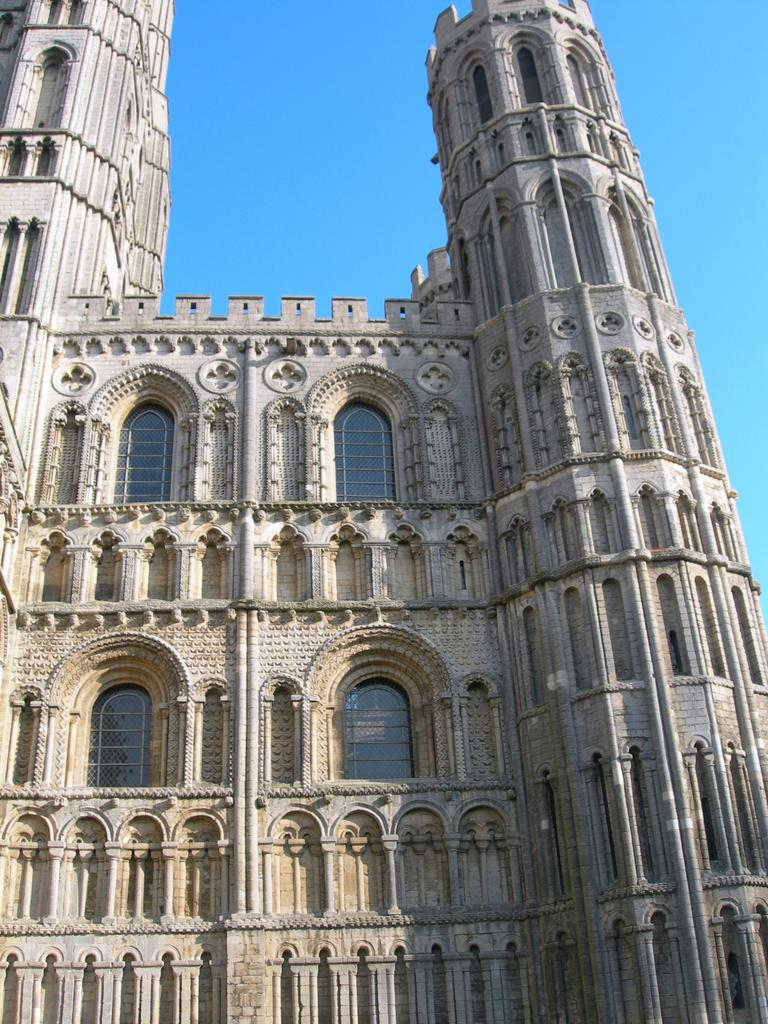What type of structure is present in the image? There is a building in the image. What can be seen above the building in the image? The sky is visible at the top of the image. How many legs does the building have in the image? Buildings do not have legs; they are stationary structures. 